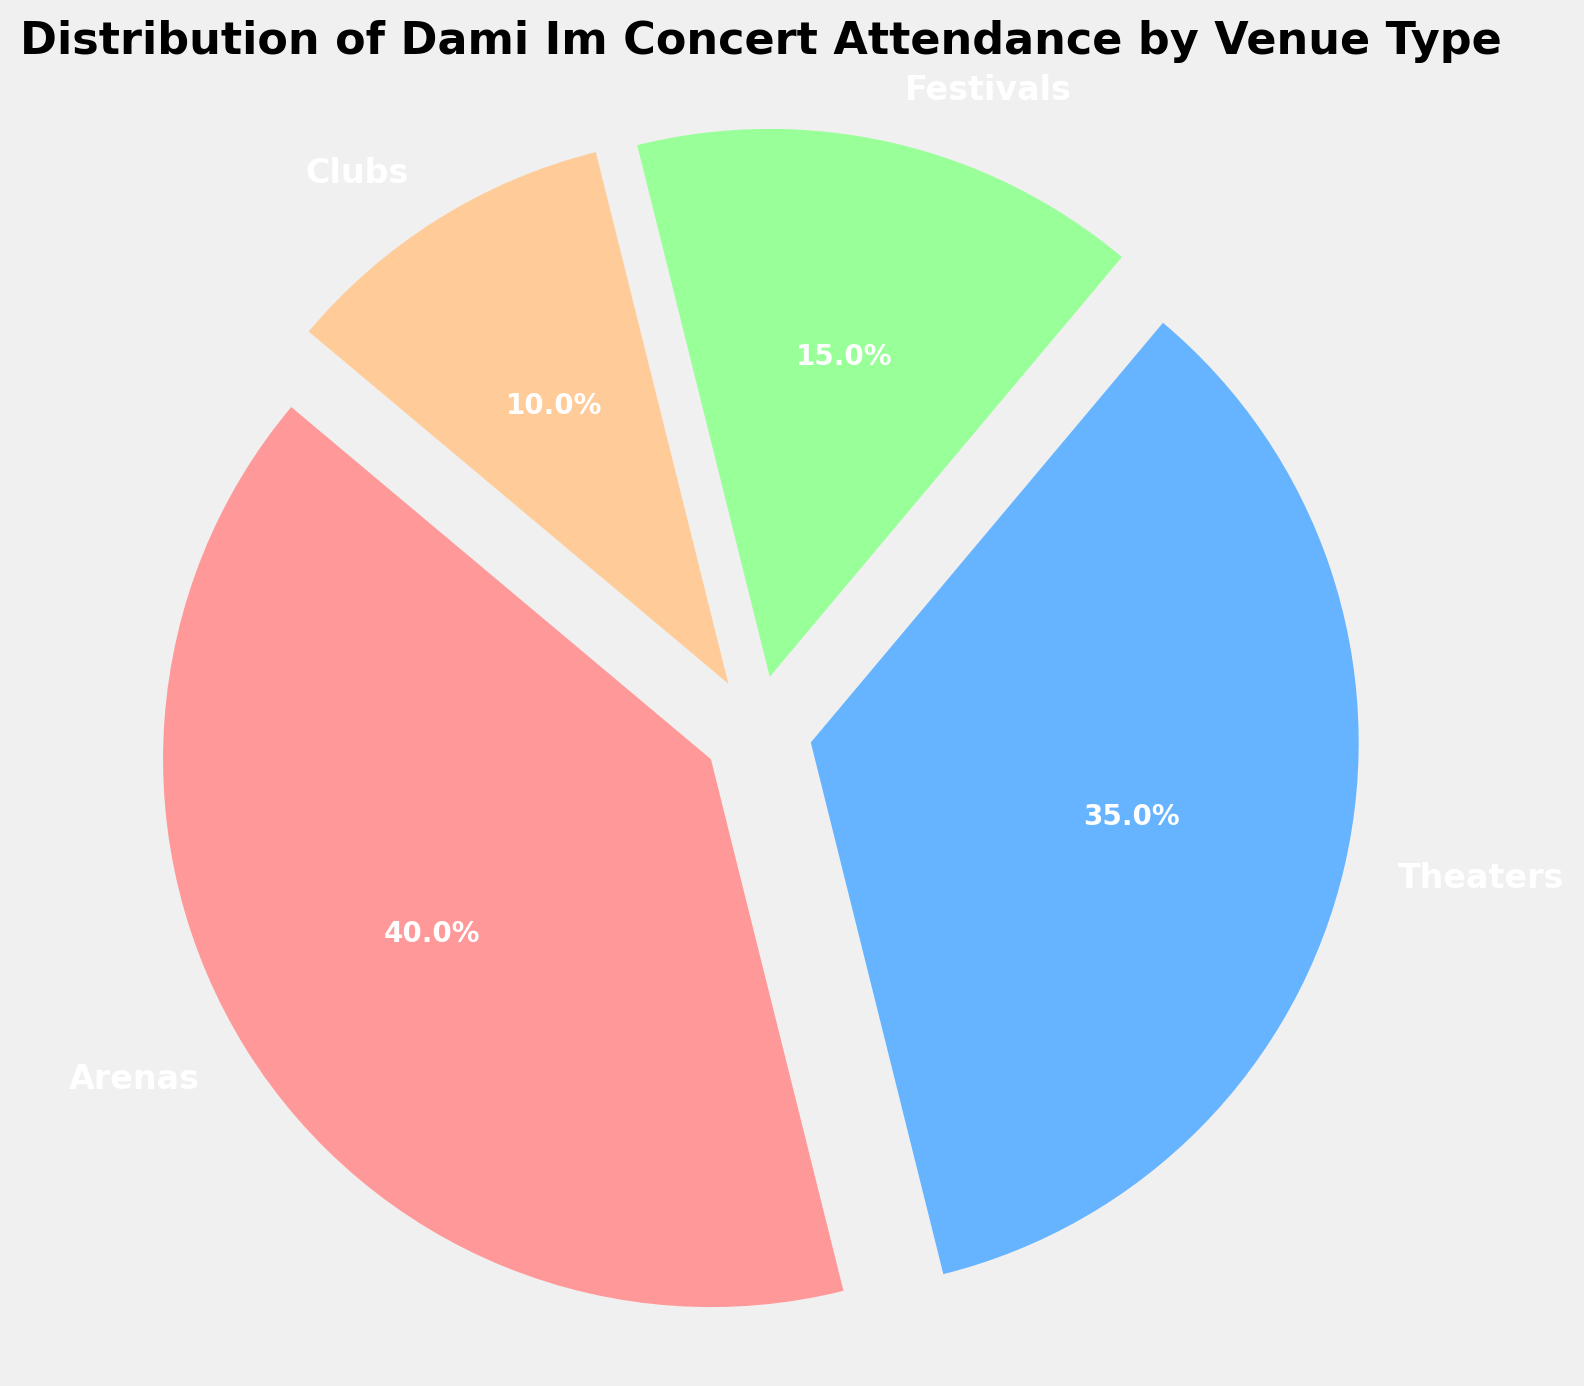What's the largest segment in the pie chart? The largest segment in the pie chart represents "Arenas" with an attendance percentage of 40%. This is evident as it takes up the largest portion of the pie.
Answer: Arenas What is the combined attendance percentage for Theaters and Festivals? The combined attendance percentage for Theaters and Festivals is the sum of their individual attendance percentages: 35% (Theaters) + 15% (Festivals) = 50%.
Answer: 50% Between Clubs and Festivals, which venue type has a higher attendance percentage? Festivals have a higher attendance percentage compared to Clubs. Festivals have 15% attendance while Clubs have 10%.
Answer: Festivals How much more attendance percentage do Arenas have compared to Clubs? Arenas have an attendance percentage of 40%, while Clubs have 10%. The difference is 40% - 10% = 30%.
Answer: 30% What percentage of concert attendance is not in Arenas? The total attendance percentage is 100%. The attendance percentage in Arenas is 40%. So, the percentage not in Arenas is 100% - 40% = 60%.
Answer: 60% If another venue type were added with 5% attendance, what would be the new total attendance percentage for Arenas and Theaters combined? The current combined attendance percentage for Arenas and Theaters is 40% + 35% = 75%. Adding 5% to the total attendance percentage doesn't change the combined value for Arenas and Theaters. It remains 75%.
Answer: 75% What color is the segment representing Clubs? The segment for Clubs is visually represented by a color similar to '#ffcc99', which can be described as a light brown or tan shade.
Answer: light brown Which venue type has the second-largest attendance percentage? Theaters have the second-largest attendance percentage at 35%, just behind Arenas at 40%.
Answer: Theaters How does the attendance percentage of Clubs compare with the other venue types? Clubs have the smallest attendance percentage of 10% compared to Arenas (40%), Theaters (35%), and Festivals (15%).
Answer: Clubs have the smallest What would be the average attendance percentage for Theaters, Festivals, and Clubs? The average attendance percentage is calculated by summing the percentages for Theaters (35%), Festivals (15%), and Clubs (10%) and dividing by 3: (35% + 15% + 10%) / 3 = 60% / 3 = 20%.
Answer: 20% 